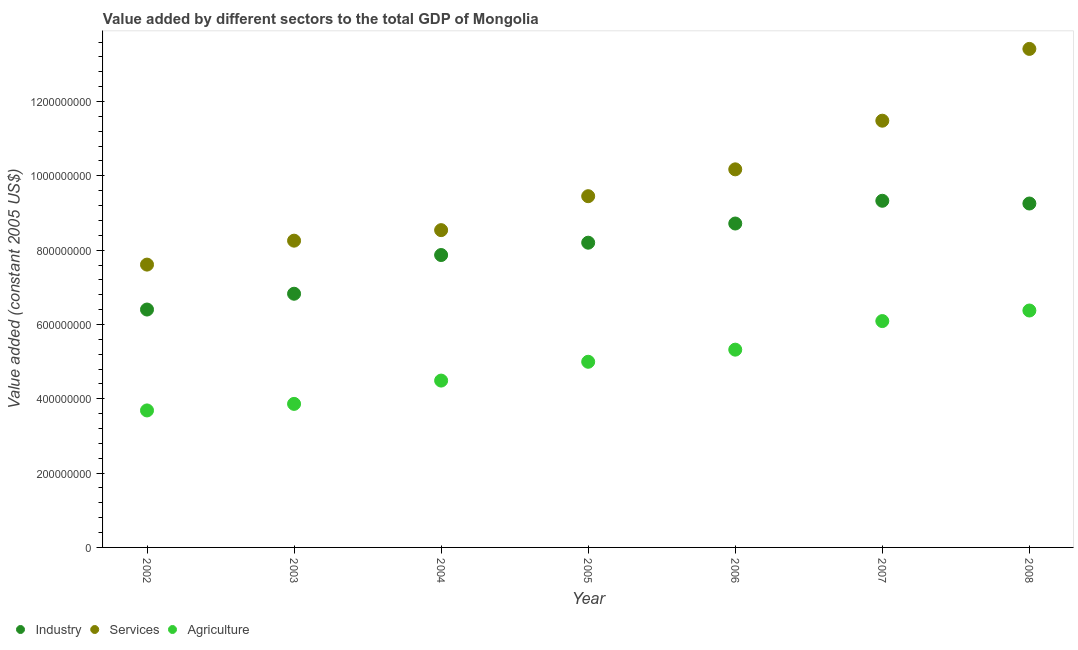What is the value added by services in 2007?
Provide a succinct answer. 1.15e+09. Across all years, what is the maximum value added by services?
Give a very brief answer. 1.34e+09. Across all years, what is the minimum value added by services?
Make the answer very short. 7.61e+08. In which year was the value added by services minimum?
Make the answer very short. 2002. What is the total value added by services in the graph?
Your answer should be very brief. 6.89e+09. What is the difference between the value added by agricultural sector in 2004 and that in 2008?
Offer a very short reply. -1.89e+08. What is the difference between the value added by agricultural sector in 2002 and the value added by services in 2008?
Ensure brevity in your answer.  -9.73e+08. What is the average value added by industrial sector per year?
Your answer should be very brief. 8.09e+08. In the year 2008, what is the difference between the value added by agricultural sector and value added by industrial sector?
Ensure brevity in your answer.  -2.88e+08. What is the ratio of the value added by agricultural sector in 2002 to that in 2005?
Give a very brief answer. 0.74. Is the difference between the value added by services in 2003 and 2004 greater than the difference between the value added by industrial sector in 2003 and 2004?
Your answer should be very brief. Yes. What is the difference between the highest and the second highest value added by industrial sector?
Offer a very short reply. 7.36e+06. What is the difference between the highest and the lowest value added by industrial sector?
Your answer should be very brief. 2.93e+08. In how many years, is the value added by agricultural sector greater than the average value added by agricultural sector taken over all years?
Ensure brevity in your answer.  4. Is the sum of the value added by agricultural sector in 2002 and 2008 greater than the maximum value added by services across all years?
Provide a short and direct response. No. Is the value added by services strictly greater than the value added by agricultural sector over the years?
Your answer should be compact. Yes. How many years are there in the graph?
Your answer should be very brief. 7. What is the difference between two consecutive major ticks on the Y-axis?
Keep it short and to the point. 2.00e+08. Does the graph contain any zero values?
Provide a short and direct response. No. How many legend labels are there?
Provide a short and direct response. 3. How are the legend labels stacked?
Offer a very short reply. Horizontal. What is the title of the graph?
Your response must be concise. Value added by different sectors to the total GDP of Mongolia. Does "Unemployment benefits" appear as one of the legend labels in the graph?
Provide a short and direct response. No. What is the label or title of the X-axis?
Offer a very short reply. Year. What is the label or title of the Y-axis?
Ensure brevity in your answer.  Value added (constant 2005 US$). What is the Value added (constant 2005 US$) of Industry in 2002?
Offer a very short reply. 6.40e+08. What is the Value added (constant 2005 US$) of Services in 2002?
Your answer should be compact. 7.61e+08. What is the Value added (constant 2005 US$) in Agriculture in 2002?
Keep it short and to the point. 3.69e+08. What is the Value added (constant 2005 US$) of Industry in 2003?
Offer a very short reply. 6.83e+08. What is the Value added (constant 2005 US$) of Services in 2003?
Provide a short and direct response. 8.25e+08. What is the Value added (constant 2005 US$) of Agriculture in 2003?
Make the answer very short. 3.86e+08. What is the Value added (constant 2005 US$) in Industry in 2004?
Provide a succinct answer. 7.87e+08. What is the Value added (constant 2005 US$) in Services in 2004?
Offer a terse response. 8.54e+08. What is the Value added (constant 2005 US$) of Agriculture in 2004?
Your answer should be compact. 4.49e+08. What is the Value added (constant 2005 US$) in Industry in 2005?
Your answer should be compact. 8.20e+08. What is the Value added (constant 2005 US$) in Services in 2005?
Provide a succinct answer. 9.45e+08. What is the Value added (constant 2005 US$) of Agriculture in 2005?
Keep it short and to the point. 5.00e+08. What is the Value added (constant 2005 US$) in Industry in 2006?
Make the answer very short. 8.72e+08. What is the Value added (constant 2005 US$) in Services in 2006?
Offer a very short reply. 1.02e+09. What is the Value added (constant 2005 US$) of Agriculture in 2006?
Your answer should be compact. 5.32e+08. What is the Value added (constant 2005 US$) of Industry in 2007?
Your response must be concise. 9.33e+08. What is the Value added (constant 2005 US$) of Services in 2007?
Provide a succinct answer. 1.15e+09. What is the Value added (constant 2005 US$) in Agriculture in 2007?
Offer a terse response. 6.09e+08. What is the Value added (constant 2005 US$) of Industry in 2008?
Your answer should be compact. 9.25e+08. What is the Value added (constant 2005 US$) of Services in 2008?
Ensure brevity in your answer.  1.34e+09. What is the Value added (constant 2005 US$) of Agriculture in 2008?
Your answer should be compact. 6.38e+08. Across all years, what is the maximum Value added (constant 2005 US$) of Industry?
Your answer should be compact. 9.33e+08. Across all years, what is the maximum Value added (constant 2005 US$) in Services?
Your answer should be very brief. 1.34e+09. Across all years, what is the maximum Value added (constant 2005 US$) in Agriculture?
Your response must be concise. 6.38e+08. Across all years, what is the minimum Value added (constant 2005 US$) in Industry?
Give a very brief answer. 6.40e+08. Across all years, what is the minimum Value added (constant 2005 US$) in Services?
Your response must be concise. 7.61e+08. Across all years, what is the minimum Value added (constant 2005 US$) in Agriculture?
Provide a succinct answer. 3.69e+08. What is the total Value added (constant 2005 US$) of Industry in the graph?
Your response must be concise. 5.66e+09. What is the total Value added (constant 2005 US$) in Services in the graph?
Offer a terse response. 6.89e+09. What is the total Value added (constant 2005 US$) in Agriculture in the graph?
Your response must be concise. 3.48e+09. What is the difference between the Value added (constant 2005 US$) of Industry in 2002 and that in 2003?
Make the answer very short. -4.25e+07. What is the difference between the Value added (constant 2005 US$) of Services in 2002 and that in 2003?
Offer a very short reply. -6.44e+07. What is the difference between the Value added (constant 2005 US$) in Agriculture in 2002 and that in 2003?
Offer a terse response. -1.76e+07. What is the difference between the Value added (constant 2005 US$) of Industry in 2002 and that in 2004?
Provide a short and direct response. -1.47e+08. What is the difference between the Value added (constant 2005 US$) of Services in 2002 and that in 2004?
Provide a short and direct response. -9.27e+07. What is the difference between the Value added (constant 2005 US$) in Agriculture in 2002 and that in 2004?
Make the answer very short. -8.03e+07. What is the difference between the Value added (constant 2005 US$) in Industry in 2002 and that in 2005?
Provide a succinct answer. -1.80e+08. What is the difference between the Value added (constant 2005 US$) in Services in 2002 and that in 2005?
Your answer should be very brief. -1.84e+08. What is the difference between the Value added (constant 2005 US$) of Agriculture in 2002 and that in 2005?
Your answer should be compact. -1.31e+08. What is the difference between the Value added (constant 2005 US$) of Industry in 2002 and that in 2006?
Your answer should be very brief. -2.31e+08. What is the difference between the Value added (constant 2005 US$) of Services in 2002 and that in 2006?
Provide a short and direct response. -2.56e+08. What is the difference between the Value added (constant 2005 US$) of Agriculture in 2002 and that in 2006?
Make the answer very short. -1.64e+08. What is the difference between the Value added (constant 2005 US$) of Industry in 2002 and that in 2007?
Keep it short and to the point. -2.93e+08. What is the difference between the Value added (constant 2005 US$) of Services in 2002 and that in 2007?
Provide a short and direct response. -3.87e+08. What is the difference between the Value added (constant 2005 US$) in Agriculture in 2002 and that in 2007?
Offer a very short reply. -2.40e+08. What is the difference between the Value added (constant 2005 US$) in Industry in 2002 and that in 2008?
Ensure brevity in your answer.  -2.85e+08. What is the difference between the Value added (constant 2005 US$) in Services in 2002 and that in 2008?
Keep it short and to the point. -5.80e+08. What is the difference between the Value added (constant 2005 US$) of Agriculture in 2002 and that in 2008?
Offer a terse response. -2.69e+08. What is the difference between the Value added (constant 2005 US$) of Industry in 2003 and that in 2004?
Ensure brevity in your answer.  -1.04e+08. What is the difference between the Value added (constant 2005 US$) in Services in 2003 and that in 2004?
Your answer should be compact. -2.83e+07. What is the difference between the Value added (constant 2005 US$) of Agriculture in 2003 and that in 2004?
Your answer should be very brief. -6.27e+07. What is the difference between the Value added (constant 2005 US$) in Industry in 2003 and that in 2005?
Your answer should be compact. -1.37e+08. What is the difference between the Value added (constant 2005 US$) of Services in 2003 and that in 2005?
Keep it short and to the point. -1.20e+08. What is the difference between the Value added (constant 2005 US$) in Agriculture in 2003 and that in 2005?
Provide a short and direct response. -1.13e+08. What is the difference between the Value added (constant 2005 US$) in Industry in 2003 and that in 2006?
Provide a short and direct response. -1.89e+08. What is the difference between the Value added (constant 2005 US$) of Services in 2003 and that in 2006?
Your response must be concise. -1.92e+08. What is the difference between the Value added (constant 2005 US$) of Agriculture in 2003 and that in 2006?
Make the answer very short. -1.46e+08. What is the difference between the Value added (constant 2005 US$) of Industry in 2003 and that in 2007?
Make the answer very short. -2.50e+08. What is the difference between the Value added (constant 2005 US$) of Services in 2003 and that in 2007?
Your response must be concise. -3.23e+08. What is the difference between the Value added (constant 2005 US$) in Agriculture in 2003 and that in 2007?
Your answer should be very brief. -2.23e+08. What is the difference between the Value added (constant 2005 US$) of Industry in 2003 and that in 2008?
Keep it short and to the point. -2.43e+08. What is the difference between the Value added (constant 2005 US$) in Services in 2003 and that in 2008?
Offer a very short reply. -5.16e+08. What is the difference between the Value added (constant 2005 US$) of Agriculture in 2003 and that in 2008?
Your response must be concise. -2.51e+08. What is the difference between the Value added (constant 2005 US$) of Industry in 2004 and that in 2005?
Provide a short and direct response. -3.32e+07. What is the difference between the Value added (constant 2005 US$) of Services in 2004 and that in 2005?
Offer a very short reply. -9.14e+07. What is the difference between the Value added (constant 2005 US$) of Agriculture in 2004 and that in 2005?
Provide a short and direct response. -5.06e+07. What is the difference between the Value added (constant 2005 US$) in Industry in 2004 and that in 2006?
Make the answer very short. -8.48e+07. What is the difference between the Value added (constant 2005 US$) of Services in 2004 and that in 2006?
Your answer should be compact. -1.64e+08. What is the difference between the Value added (constant 2005 US$) of Agriculture in 2004 and that in 2006?
Your response must be concise. -8.33e+07. What is the difference between the Value added (constant 2005 US$) of Industry in 2004 and that in 2007?
Provide a short and direct response. -1.46e+08. What is the difference between the Value added (constant 2005 US$) in Services in 2004 and that in 2007?
Ensure brevity in your answer.  -2.95e+08. What is the difference between the Value added (constant 2005 US$) in Agriculture in 2004 and that in 2007?
Provide a short and direct response. -1.60e+08. What is the difference between the Value added (constant 2005 US$) in Industry in 2004 and that in 2008?
Keep it short and to the point. -1.39e+08. What is the difference between the Value added (constant 2005 US$) of Services in 2004 and that in 2008?
Give a very brief answer. -4.88e+08. What is the difference between the Value added (constant 2005 US$) of Agriculture in 2004 and that in 2008?
Make the answer very short. -1.89e+08. What is the difference between the Value added (constant 2005 US$) of Industry in 2005 and that in 2006?
Provide a succinct answer. -5.16e+07. What is the difference between the Value added (constant 2005 US$) of Services in 2005 and that in 2006?
Ensure brevity in your answer.  -7.23e+07. What is the difference between the Value added (constant 2005 US$) of Agriculture in 2005 and that in 2006?
Your answer should be very brief. -3.26e+07. What is the difference between the Value added (constant 2005 US$) of Industry in 2005 and that in 2007?
Your answer should be very brief. -1.13e+08. What is the difference between the Value added (constant 2005 US$) of Services in 2005 and that in 2007?
Your response must be concise. -2.03e+08. What is the difference between the Value added (constant 2005 US$) of Agriculture in 2005 and that in 2007?
Provide a succinct answer. -1.09e+08. What is the difference between the Value added (constant 2005 US$) in Industry in 2005 and that in 2008?
Provide a short and direct response. -1.05e+08. What is the difference between the Value added (constant 2005 US$) in Services in 2005 and that in 2008?
Provide a succinct answer. -3.96e+08. What is the difference between the Value added (constant 2005 US$) of Agriculture in 2005 and that in 2008?
Offer a very short reply. -1.38e+08. What is the difference between the Value added (constant 2005 US$) of Industry in 2006 and that in 2007?
Your answer should be very brief. -6.12e+07. What is the difference between the Value added (constant 2005 US$) of Services in 2006 and that in 2007?
Give a very brief answer. -1.31e+08. What is the difference between the Value added (constant 2005 US$) of Agriculture in 2006 and that in 2007?
Make the answer very short. -7.69e+07. What is the difference between the Value added (constant 2005 US$) in Industry in 2006 and that in 2008?
Your response must be concise. -5.38e+07. What is the difference between the Value added (constant 2005 US$) in Services in 2006 and that in 2008?
Provide a succinct answer. -3.24e+08. What is the difference between the Value added (constant 2005 US$) of Agriculture in 2006 and that in 2008?
Give a very brief answer. -1.05e+08. What is the difference between the Value added (constant 2005 US$) in Industry in 2007 and that in 2008?
Offer a terse response. 7.36e+06. What is the difference between the Value added (constant 2005 US$) of Services in 2007 and that in 2008?
Make the answer very short. -1.93e+08. What is the difference between the Value added (constant 2005 US$) in Agriculture in 2007 and that in 2008?
Give a very brief answer. -2.85e+07. What is the difference between the Value added (constant 2005 US$) of Industry in 2002 and the Value added (constant 2005 US$) of Services in 2003?
Your response must be concise. -1.85e+08. What is the difference between the Value added (constant 2005 US$) in Industry in 2002 and the Value added (constant 2005 US$) in Agriculture in 2003?
Give a very brief answer. 2.54e+08. What is the difference between the Value added (constant 2005 US$) of Services in 2002 and the Value added (constant 2005 US$) of Agriculture in 2003?
Offer a terse response. 3.75e+08. What is the difference between the Value added (constant 2005 US$) in Industry in 2002 and the Value added (constant 2005 US$) in Services in 2004?
Give a very brief answer. -2.14e+08. What is the difference between the Value added (constant 2005 US$) of Industry in 2002 and the Value added (constant 2005 US$) of Agriculture in 2004?
Provide a short and direct response. 1.91e+08. What is the difference between the Value added (constant 2005 US$) in Services in 2002 and the Value added (constant 2005 US$) in Agriculture in 2004?
Provide a short and direct response. 3.12e+08. What is the difference between the Value added (constant 2005 US$) of Industry in 2002 and the Value added (constant 2005 US$) of Services in 2005?
Provide a succinct answer. -3.05e+08. What is the difference between the Value added (constant 2005 US$) of Industry in 2002 and the Value added (constant 2005 US$) of Agriculture in 2005?
Give a very brief answer. 1.41e+08. What is the difference between the Value added (constant 2005 US$) of Services in 2002 and the Value added (constant 2005 US$) of Agriculture in 2005?
Your answer should be very brief. 2.61e+08. What is the difference between the Value added (constant 2005 US$) of Industry in 2002 and the Value added (constant 2005 US$) of Services in 2006?
Make the answer very short. -3.77e+08. What is the difference between the Value added (constant 2005 US$) in Industry in 2002 and the Value added (constant 2005 US$) in Agriculture in 2006?
Make the answer very short. 1.08e+08. What is the difference between the Value added (constant 2005 US$) of Services in 2002 and the Value added (constant 2005 US$) of Agriculture in 2006?
Offer a terse response. 2.29e+08. What is the difference between the Value added (constant 2005 US$) in Industry in 2002 and the Value added (constant 2005 US$) in Services in 2007?
Keep it short and to the point. -5.08e+08. What is the difference between the Value added (constant 2005 US$) of Industry in 2002 and the Value added (constant 2005 US$) of Agriculture in 2007?
Provide a short and direct response. 3.11e+07. What is the difference between the Value added (constant 2005 US$) in Services in 2002 and the Value added (constant 2005 US$) in Agriculture in 2007?
Keep it short and to the point. 1.52e+08. What is the difference between the Value added (constant 2005 US$) of Industry in 2002 and the Value added (constant 2005 US$) of Services in 2008?
Give a very brief answer. -7.01e+08. What is the difference between the Value added (constant 2005 US$) in Industry in 2002 and the Value added (constant 2005 US$) in Agriculture in 2008?
Your answer should be very brief. 2.63e+06. What is the difference between the Value added (constant 2005 US$) in Services in 2002 and the Value added (constant 2005 US$) in Agriculture in 2008?
Provide a short and direct response. 1.24e+08. What is the difference between the Value added (constant 2005 US$) of Industry in 2003 and the Value added (constant 2005 US$) of Services in 2004?
Offer a very short reply. -1.71e+08. What is the difference between the Value added (constant 2005 US$) of Industry in 2003 and the Value added (constant 2005 US$) of Agriculture in 2004?
Ensure brevity in your answer.  2.34e+08. What is the difference between the Value added (constant 2005 US$) of Services in 2003 and the Value added (constant 2005 US$) of Agriculture in 2004?
Provide a short and direct response. 3.77e+08. What is the difference between the Value added (constant 2005 US$) of Industry in 2003 and the Value added (constant 2005 US$) of Services in 2005?
Provide a short and direct response. -2.62e+08. What is the difference between the Value added (constant 2005 US$) of Industry in 2003 and the Value added (constant 2005 US$) of Agriculture in 2005?
Make the answer very short. 1.83e+08. What is the difference between the Value added (constant 2005 US$) in Services in 2003 and the Value added (constant 2005 US$) in Agriculture in 2005?
Make the answer very short. 3.26e+08. What is the difference between the Value added (constant 2005 US$) in Industry in 2003 and the Value added (constant 2005 US$) in Services in 2006?
Make the answer very short. -3.35e+08. What is the difference between the Value added (constant 2005 US$) in Industry in 2003 and the Value added (constant 2005 US$) in Agriculture in 2006?
Your answer should be compact. 1.50e+08. What is the difference between the Value added (constant 2005 US$) in Services in 2003 and the Value added (constant 2005 US$) in Agriculture in 2006?
Your response must be concise. 2.93e+08. What is the difference between the Value added (constant 2005 US$) of Industry in 2003 and the Value added (constant 2005 US$) of Services in 2007?
Provide a succinct answer. -4.66e+08. What is the difference between the Value added (constant 2005 US$) of Industry in 2003 and the Value added (constant 2005 US$) of Agriculture in 2007?
Offer a very short reply. 7.36e+07. What is the difference between the Value added (constant 2005 US$) of Services in 2003 and the Value added (constant 2005 US$) of Agriculture in 2007?
Offer a terse response. 2.16e+08. What is the difference between the Value added (constant 2005 US$) in Industry in 2003 and the Value added (constant 2005 US$) in Services in 2008?
Give a very brief answer. -6.59e+08. What is the difference between the Value added (constant 2005 US$) in Industry in 2003 and the Value added (constant 2005 US$) in Agriculture in 2008?
Provide a succinct answer. 4.51e+07. What is the difference between the Value added (constant 2005 US$) of Services in 2003 and the Value added (constant 2005 US$) of Agriculture in 2008?
Give a very brief answer. 1.88e+08. What is the difference between the Value added (constant 2005 US$) of Industry in 2004 and the Value added (constant 2005 US$) of Services in 2005?
Ensure brevity in your answer.  -1.58e+08. What is the difference between the Value added (constant 2005 US$) in Industry in 2004 and the Value added (constant 2005 US$) in Agriculture in 2005?
Your answer should be compact. 2.87e+08. What is the difference between the Value added (constant 2005 US$) in Services in 2004 and the Value added (constant 2005 US$) in Agriculture in 2005?
Provide a succinct answer. 3.54e+08. What is the difference between the Value added (constant 2005 US$) of Industry in 2004 and the Value added (constant 2005 US$) of Services in 2006?
Ensure brevity in your answer.  -2.31e+08. What is the difference between the Value added (constant 2005 US$) of Industry in 2004 and the Value added (constant 2005 US$) of Agriculture in 2006?
Keep it short and to the point. 2.55e+08. What is the difference between the Value added (constant 2005 US$) of Services in 2004 and the Value added (constant 2005 US$) of Agriculture in 2006?
Make the answer very short. 3.22e+08. What is the difference between the Value added (constant 2005 US$) of Industry in 2004 and the Value added (constant 2005 US$) of Services in 2007?
Provide a short and direct response. -3.61e+08. What is the difference between the Value added (constant 2005 US$) in Industry in 2004 and the Value added (constant 2005 US$) in Agriculture in 2007?
Your answer should be very brief. 1.78e+08. What is the difference between the Value added (constant 2005 US$) of Services in 2004 and the Value added (constant 2005 US$) of Agriculture in 2007?
Give a very brief answer. 2.45e+08. What is the difference between the Value added (constant 2005 US$) in Industry in 2004 and the Value added (constant 2005 US$) in Services in 2008?
Offer a very short reply. -5.55e+08. What is the difference between the Value added (constant 2005 US$) of Industry in 2004 and the Value added (constant 2005 US$) of Agriculture in 2008?
Your answer should be very brief. 1.49e+08. What is the difference between the Value added (constant 2005 US$) of Services in 2004 and the Value added (constant 2005 US$) of Agriculture in 2008?
Provide a short and direct response. 2.16e+08. What is the difference between the Value added (constant 2005 US$) of Industry in 2005 and the Value added (constant 2005 US$) of Services in 2006?
Your answer should be very brief. -1.97e+08. What is the difference between the Value added (constant 2005 US$) in Industry in 2005 and the Value added (constant 2005 US$) in Agriculture in 2006?
Your response must be concise. 2.88e+08. What is the difference between the Value added (constant 2005 US$) of Services in 2005 and the Value added (constant 2005 US$) of Agriculture in 2006?
Make the answer very short. 4.13e+08. What is the difference between the Value added (constant 2005 US$) in Industry in 2005 and the Value added (constant 2005 US$) in Services in 2007?
Give a very brief answer. -3.28e+08. What is the difference between the Value added (constant 2005 US$) of Industry in 2005 and the Value added (constant 2005 US$) of Agriculture in 2007?
Your answer should be very brief. 2.11e+08. What is the difference between the Value added (constant 2005 US$) of Services in 2005 and the Value added (constant 2005 US$) of Agriculture in 2007?
Keep it short and to the point. 3.36e+08. What is the difference between the Value added (constant 2005 US$) in Industry in 2005 and the Value added (constant 2005 US$) in Services in 2008?
Give a very brief answer. -5.22e+08. What is the difference between the Value added (constant 2005 US$) of Industry in 2005 and the Value added (constant 2005 US$) of Agriculture in 2008?
Your answer should be very brief. 1.82e+08. What is the difference between the Value added (constant 2005 US$) of Services in 2005 and the Value added (constant 2005 US$) of Agriculture in 2008?
Give a very brief answer. 3.08e+08. What is the difference between the Value added (constant 2005 US$) of Industry in 2006 and the Value added (constant 2005 US$) of Services in 2007?
Provide a short and direct response. -2.77e+08. What is the difference between the Value added (constant 2005 US$) of Industry in 2006 and the Value added (constant 2005 US$) of Agriculture in 2007?
Provide a succinct answer. 2.63e+08. What is the difference between the Value added (constant 2005 US$) in Services in 2006 and the Value added (constant 2005 US$) in Agriculture in 2007?
Your answer should be very brief. 4.08e+08. What is the difference between the Value added (constant 2005 US$) of Industry in 2006 and the Value added (constant 2005 US$) of Services in 2008?
Give a very brief answer. -4.70e+08. What is the difference between the Value added (constant 2005 US$) of Industry in 2006 and the Value added (constant 2005 US$) of Agriculture in 2008?
Your response must be concise. 2.34e+08. What is the difference between the Value added (constant 2005 US$) in Services in 2006 and the Value added (constant 2005 US$) in Agriculture in 2008?
Keep it short and to the point. 3.80e+08. What is the difference between the Value added (constant 2005 US$) of Industry in 2007 and the Value added (constant 2005 US$) of Services in 2008?
Ensure brevity in your answer.  -4.09e+08. What is the difference between the Value added (constant 2005 US$) in Industry in 2007 and the Value added (constant 2005 US$) in Agriculture in 2008?
Keep it short and to the point. 2.95e+08. What is the difference between the Value added (constant 2005 US$) in Services in 2007 and the Value added (constant 2005 US$) in Agriculture in 2008?
Keep it short and to the point. 5.11e+08. What is the average Value added (constant 2005 US$) in Industry per year?
Provide a short and direct response. 8.09e+08. What is the average Value added (constant 2005 US$) of Services per year?
Ensure brevity in your answer.  9.85e+08. What is the average Value added (constant 2005 US$) in Agriculture per year?
Give a very brief answer. 4.97e+08. In the year 2002, what is the difference between the Value added (constant 2005 US$) in Industry and Value added (constant 2005 US$) in Services?
Provide a succinct answer. -1.21e+08. In the year 2002, what is the difference between the Value added (constant 2005 US$) in Industry and Value added (constant 2005 US$) in Agriculture?
Make the answer very short. 2.72e+08. In the year 2002, what is the difference between the Value added (constant 2005 US$) in Services and Value added (constant 2005 US$) in Agriculture?
Offer a very short reply. 3.92e+08. In the year 2003, what is the difference between the Value added (constant 2005 US$) of Industry and Value added (constant 2005 US$) of Services?
Make the answer very short. -1.43e+08. In the year 2003, what is the difference between the Value added (constant 2005 US$) of Industry and Value added (constant 2005 US$) of Agriculture?
Ensure brevity in your answer.  2.96e+08. In the year 2003, what is the difference between the Value added (constant 2005 US$) in Services and Value added (constant 2005 US$) in Agriculture?
Offer a very short reply. 4.39e+08. In the year 2004, what is the difference between the Value added (constant 2005 US$) of Industry and Value added (constant 2005 US$) of Services?
Provide a short and direct response. -6.70e+07. In the year 2004, what is the difference between the Value added (constant 2005 US$) of Industry and Value added (constant 2005 US$) of Agriculture?
Your answer should be compact. 3.38e+08. In the year 2004, what is the difference between the Value added (constant 2005 US$) in Services and Value added (constant 2005 US$) in Agriculture?
Provide a succinct answer. 4.05e+08. In the year 2005, what is the difference between the Value added (constant 2005 US$) of Industry and Value added (constant 2005 US$) of Services?
Offer a terse response. -1.25e+08. In the year 2005, what is the difference between the Value added (constant 2005 US$) of Industry and Value added (constant 2005 US$) of Agriculture?
Provide a succinct answer. 3.20e+08. In the year 2005, what is the difference between the Value added (constant 2005 US$) in Services and Value added (constant 2005 US$) in Agriculture?
Offer a very short reply. 4.46e+08. In the year 2006, what is the difference between the Value added (constant 2005 US$) of Industry and Value added (constant 2005 US$) of Services?
Ensure brevity in your answer.  -1.46e+08. In the year 2006, what is the difference between the Value added (constant 2005 US$) in Industry and Value added (constant 2005 US$) in Agriculture?
Your response must be concise. 3.39e+08. In the year 2006, what is the difference between the Value added (constant 2005 US$) in Services and Value added (constant 2005 US$) in Agriculture?
Your answer should be compact. 4.85e+08. In the year 2007, what is the difference between the Value added (constant 2005 US$) of Industry and Value added (constant 2005 US$) of Services?
Provide a succinct answer. -2.15e+08. In the year 2007, what is the difference between the Value added (constant 2005 US$) in Industry and Value added (constant 2005 US$) in Agriculture?
Your response must be concise. 3.24e+08. In the year 2007, what is the difference between the Value added (constant 2005 US$) of Services and Value added (constant 2005 US$) of Agriculture?
Keep it short and to the point. 5.39e+08. In the year 2008, what is the difference between the Value added (constant 2005 US$) in Industry and Value added (constant 2005 US$) in Services?
Give a very brief answer. -4.16e+08. In the year 2008, what is the difference between the Value added (constant 2005 US$) of Industry and Value added (constant 2005 US$) of Agriculture?
Offer a very short reply. 2.88e+08. In the year 2008, what is the difference between the Value added (constant 2005 US$) in Services and Value added (constant 2005 US$) in Agriculture?
Offer a terse response. 7.04e+08. What is the ratio of the Value added (constant 2005 US$) of Industry in 2002 to that in 2003?
Ensure brevity in your answer.  0.94. What is the ratio of the Value added (constant 2005 US$) of Services in 2002 to that in 2003?
Give a very brief answer. 0.92. What is the ratio of the Value added (constant 2005 US$) of Agriculture in 2002 to that in 2003?
Make the answer very short. 0.95. What is the ratio of the Value added (constant 2005 US$) in Industry in 2002 to that in 2004?
Your response must be concise. 0.81. What is the ratio of the Value added (constant 2005 US$) in Services in 2002 to that in 2004?
Your response must be concise. 0.89. What is the ratio of the Value added (constant 2005 US$) in Agriculture in 2002 to that in 2004?
Offer a very short reply. 0.82. What is the ratio of the Value added (constant 2005 US$) in Industry in 2002 to that in 2005?
Provide a short and direct response. 0.78. What is the ratio of the Value added (constant 2005 US$) of Services in 2002 to that in 2005?
Give a very brief answer. 0.81. What is the ratio of the Value added (constant 2005 US$) in Agriculture in 2002 to that in 2005?
Provide a short and direct response. 0.74. What is the ratio of the Value added (constant 2005 US$) of Industry in 2002 to that in 2006?
Provide a succinct answer. 0.73. What is the ratio of the Value added (constant 2005 US$) in Services in 2002 to that in 2006?
Offer a terse response. 0.75. What is the ratio of the Value added (constant 2005 US$) in Agriculture in 2002 to that in 2006?
Keep it short and to the point. 0.69. What is the ratio of the Value added (constant 2005 US$) of Industry in 2002 to that in 2007?
Your response must be concise. 0.69. What is the ratio of the Value added (constant 2005 US$) of Services in 2002 to that in 2007?
Keep it short and to the point. 0.66. What is the ratio of the Value added (constant 2005 US$) in Agriculture in 2002 to that in 2007?
Offer a very short reply. 0.61. What is the ratio of the Value added (constant 2005 US$) of Industry in 2002 to that in 2008?
Keep it short and to the point. 0.69. What is the ratio of the Value added (constant 2005 US$) in Services in 2002 to that in 2008?
Your answer should be very brief. 0.57. What is the ratio of the Value added (constant 2005 US$) of Agriculture in 2002 to that in 2008?
Your response must be concise. 0.58. What is the ratio of the Value added (constant 2005 US$) of Industry in 2003 to that in 2004?
Offer a very short reply. 0.87. What is the ratio of the Value added (constant 2005 US$) of Services in 2003 to that in 2004?
Your answer should be compact. 0.97. What is the ratio of the Value added (constant 2005 US$) in Agriculture in 2003 to that in 2004?
Ensure brevity in your answer.  0.86. What is the ratio of the Value added (constant 2005 US$) of Industry in 2003 to that in 2005?
Provide a short and direct response. 0.83. What is the ratio of the Value added (constant 2005 US$) of Services in 2003 to that in 2005?
Your response must be concise. 0.87. What is the ratio of the Value added (constant 2005 US$) of Agriculture in 2003 to that in 2005?
Your answer should be compact. 0.77. What is the ratio of the Value added (constant 2005 US$) in Industry in 2003 to that in 2006?
Make the answer very short. 0.78. What is the ratio of the Value added (constant 2005 US$) in Services in 2003 to that in 2006?
Keep it short and to the point. 0.81. What is the ratio of the Value added (constant 2005 US$) in Agriculture in 2003 to that in 2006?
Provide a succinct answer. 0.73. What is the ratio of the Value added (constant 2005 US$) of Industry in 2003 to that in 2007?
Your answer should be very brief. 0.73. What is the ratio of the Value added (constant 2005 US$) in Services in 2003 to that in 2007?
Your answer should be compact. 0.72. What is the ratio of the Value added (constant 2005 US$) of Agriculture in 2003 to that in 2007?
Make the answer very short. 0.63. What is the ratio of the Value added (constant 2005 US$) of Industry in 2003 to that in 2008?
Your response must be concise. 0.74. What is the ratio of the Value added (constant 2005 US$) in Services in 2003 to that in 2008?
Keep it short and to the point. 0.62. What is the ratio of the Value added (constant 2005 US$) of Agriculture in 2003 to that in 2008?
Offer a terse response. 0.61. What is the ratio of the Value added (constant 2005 US$) in Industry in 2004 to that in 2005?
Keep it short and to the point. 0.96. What is the ratio of the Value added (constant 2005 US$) of Services in 2004 to that in 2005?
Your response must be concise. 0.9. What is the ratio of the Value added (constant 2005 US$) in Agriculture in 2004 to that in 2005?
Your response must be concise. 0.9. What is the ratio of the Value added (constant 2005 US$) in Industry in 2004 to that in 2006?
Your response must be concise. 0.9. What is the ratio of the Value added (constant 2005 US$) in Services in 2004 to that in 2006?
Keep it short and to the point. 0.84. What is the ratio of the Value added (constant 2005 US$) of Agriculture in 2004 to that in 2006?
Provide a succinct answer. 0.84. What is the ratio of the Value added (constant 2005 US$) in Industry in 2004 to that in 2007?
Keep it short and to the point. 0.84. What is the ratio of the Value added (constant 2005 US$) in Services in 2004 to that in 2007?
Give a very brief answer. 0.74. What is the ratio of the Value added (constant 2005 US$) of Agriculture in 2004 to that in 2007?
Your answer should be very brief. 0.74. What is the ratio of the Value added (constant 2005 US$) in Industry in 2004 to that in 2008?
Ensure brevity in your answer.  0.85. What is the ratio of the Value added (constant 2005 US$) of Services in 2004 to that in 2008?
Provide a succinct answer. 0.64. What is the ratio of the Value added (constant 2005 US$) of Agriculture in 2004 to that in 2008?
Your answer should be very brief. 0.7. What is the ratio of the Value added (constant 2005 US$) of Industry in 2005 to that in 2006?
Offer a terse response. 0.94. What is the ratio of the Value added (constant 2005 US$) of Services in 2005 to that in 2006?
Your answer should be compact. 0.93. What is the ratio of the Value added (constant 2005 US$) in Agriculture in 2005 to that in 2006?
Keep it short and to the point. 0.94. What is the ratio of the Value added (constant 2005 US$) in Industry in 2005 to that in 2007?
Make the answer very short. 0.88. What is the ratio of the Value added (constant 2005 US$) in Services in 2005 to that in 2007?
Give a very brief answer. 0.82. What is the ratio of the Value added (constant 2005 US$) in Agriculture in 2005 to that in 2007?
Offer a terse response. 0.82. What is the ratio of the Value added (constant 2005 US$) in Industry in 2005 to that in 2008?
Offer a terse response. 0.89. What is the ratio of the Value added (constant 2005 US$) in Services in 2005 to that in 2008?
Make the answer very short. 0.7. What is the ratio of the Value added (constant 2005 US$) of Agriculture in 2005 to that in 2008?
Give a very brief answer. 0.78. What is the ratio of the Value added (constant 2005 US$) in Industry in 2006 to that in 2007?
Make the answer very short. 0.93. What is the ratio of the Value added (constant 2005 US$) of Services in 2006 to that in 2007?
Your answer should be very brief. 0.89. What is the ratio of the Value added (constant 2005 US$) in Agriculture in 2006 to that in 2007?
Give a very brief answer. 0.87. What is the ratio of the Value added (constant 2005 US$) in Industry in 2006 to that in 2008?
Make the answer very short. 0.94. What is the ratio of the Value added (constant 2005 US$) of Services in 2006 to that in 2008?
Offer a terse response. 0.76. What is the ratio of the Value added (constant 2005 US$) in Agriculture in 2006 to that in 2008?
Keep it short and to the point. 0.83. What is the ratio of the Value added (constant 2005 US$) of Services in 2007 to that in 2008?
Offer a very short reply. 0.86. What is the ratio of the Value added (constant 2005 US$) of Agriculture in 2007 to that in 2008?
Make the answer very short. 0.96. What is the difference between the highest and the second highest Value added (constant 2005 US$) of Industry?
Provide a succinct answer. 7.36e+06. What is the difference between the highest and the second highest Value added (constant 2005 US$) in Services?
Your answer should be compact. 1.93e+08. What is the difference between the highest and the second highest Value added (constant 2005 US$) in Agriculture?
Your answer should be very brief. 2.85e+07. What is the difference between the highest and the lowest Value added (constant 2005 US$) of Industry?
Provide a short and direct response. 2.93e+08. What is the difference between the highest and the lowest Value added (constant 2005 US$) in Services?
Provide a short and direct response. 5.80e+08. What is the difference between the highest and the lowest Value added (constant 2005 US$) of Agriculture?
Give a very brief answer. 2.69e+08. 